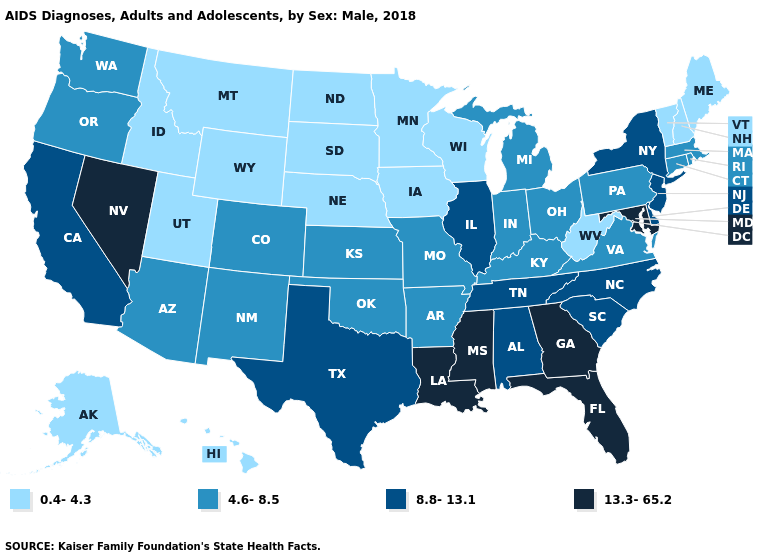Among the states that border New Jersey , which have the lowest value?
Quick response, please. Pennsylvania. What is the lowest value in the USA?
Keep it brief. 0.4-4.3. Name the states that have a value in the range 0.4-4.3?
Keep it brief. Alaska, Hawaii, Idaho, Iowa, Maine, Minnesota, Montana, Nebraska, New Hampshire, North Dakota, South Dakota, Utah, Vermont, West Virginia, Wisconsin, Wyoming. What is the value of North Dakota?
Quick response, please. 0.4-4.3. Which states have the lowest value in the South?
Quick response, please. West Virginia. What is the value of Michigan?
Write a very short answer. 4.6-8.5. What is the highest value in states that border Texas?
Quick response, please. 13.3-65.2. What is the value of Kentucky?
Give a very brief answer. 4.6-8.5. Name the states that have a value in the range 0.4-4.3?
Short answer required. Alaska, Hawaii, Idaho, Iowa, Maine, Minnesota, Montana, Nebraska, New Hampshire, North Dakota, South Dakota, Utah, Vermont, West Virginia, Wisconsin, Wyoming. What is the value of Kansas?
Short answer required. 4.6-8.5. Which states hav the highest value in the South?
Write a very short answer. Florida, Georgia, Louisiana, Maryland, Mississippi. Name the states that have a value in the range 4.6-8.5?
Short answer required. Arizona, Arkansas, Colorado, Connecticut, Indiana, Kansas, Kentucky, Massachusetts, Michigan, Missouri, New Mexico, Ohio, Oklahoma, Oregon, Pennsylvania, Rhode Island, Virginia, Washington. What is the highest value in the USA?
Give a very brief answer. 13.3-65.2. Name the states that have a value in the range 4.6-8.5?
Concise answer only. Arizona, Arkansas, Colorado, Connecticut, Indiana, Kansas, Kentucky, Massachusetts, Michigan, Missouri, New Mexico, Ohio, Oklahoma, Oregon, Pennsylvania, Rhode Island, Virginia, Washington. 